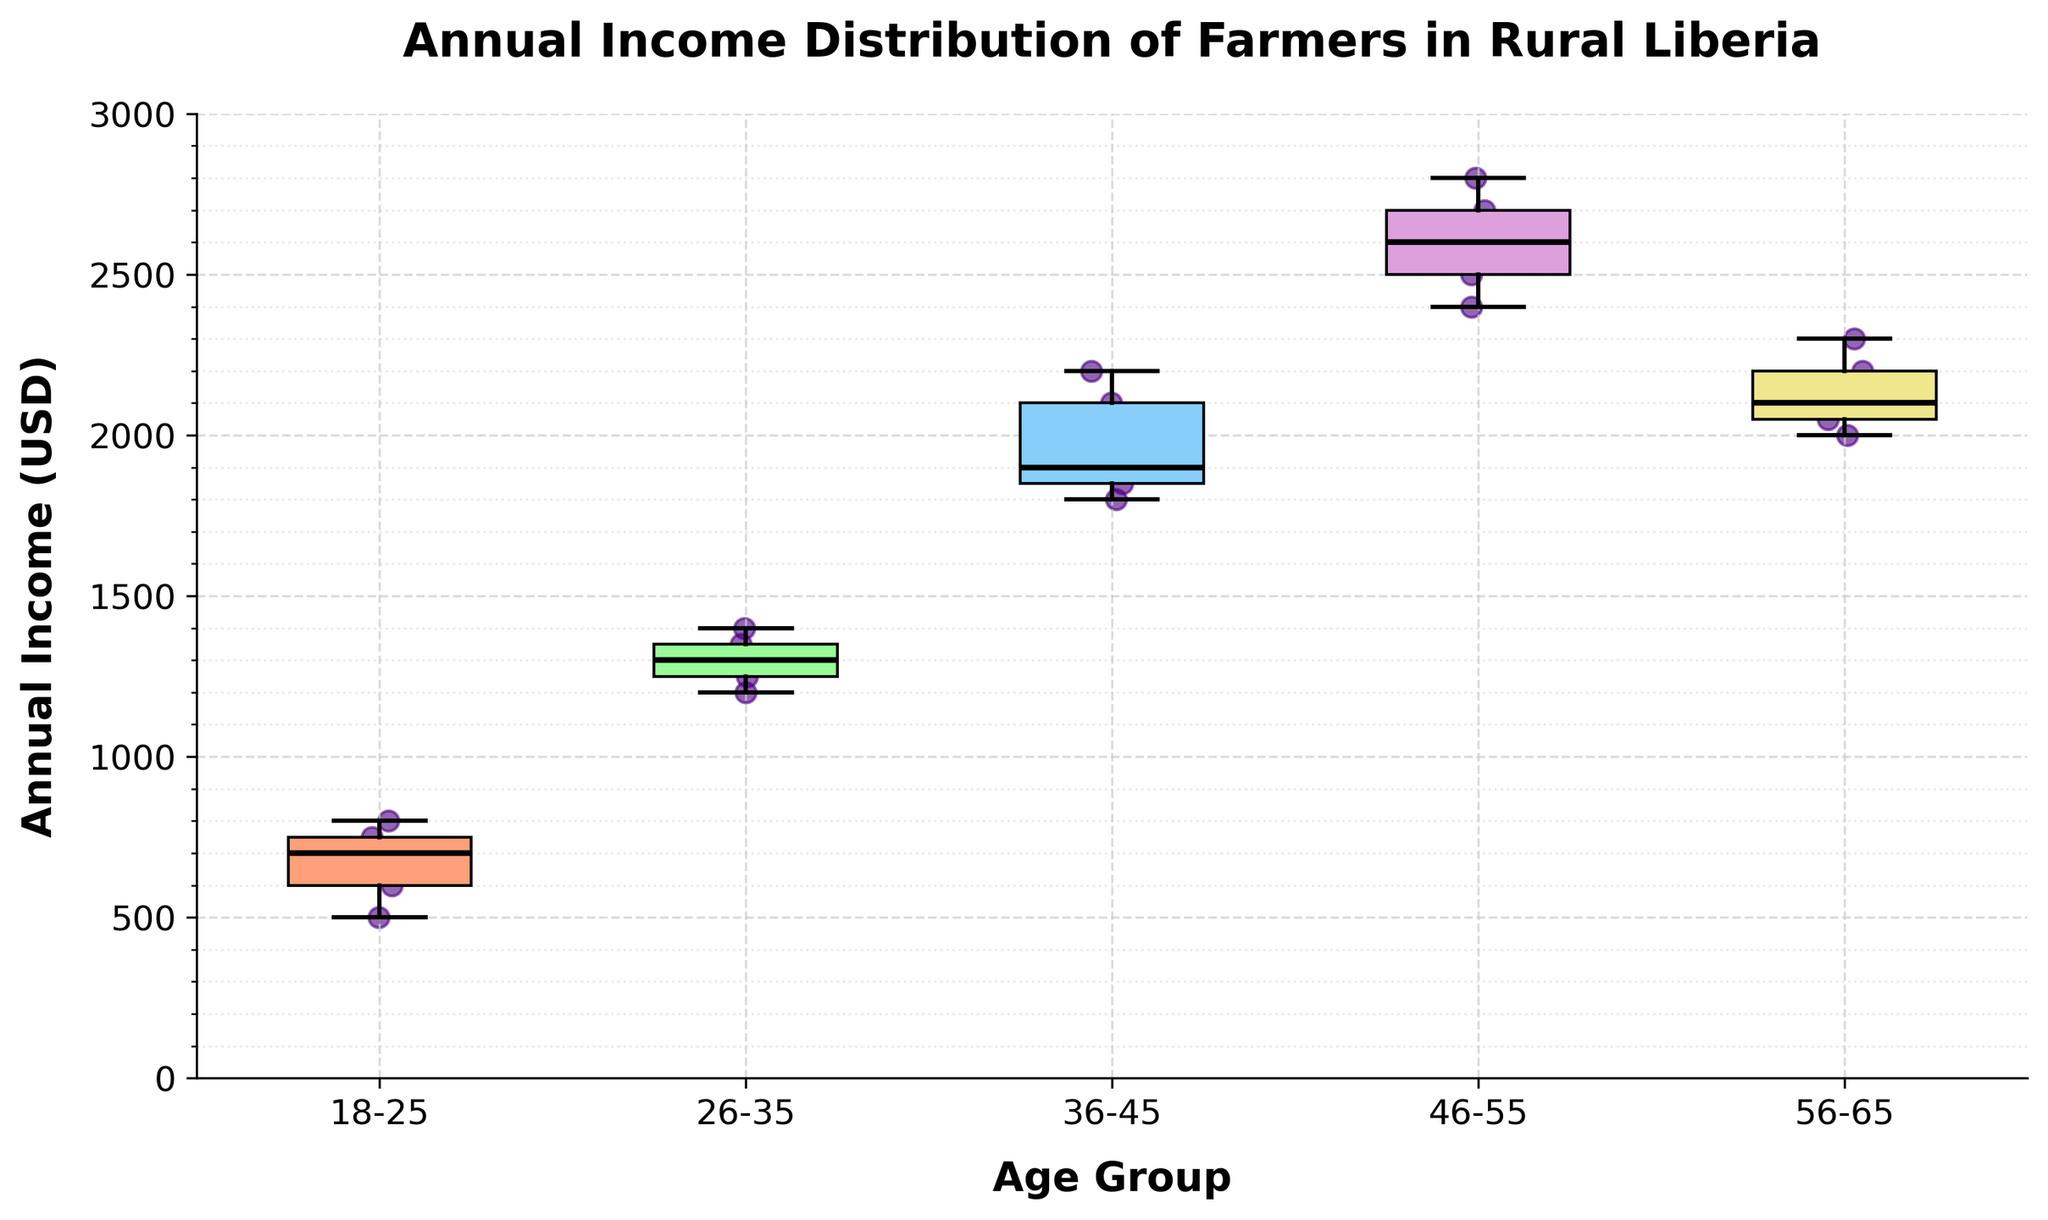What is the title of the box plot? The title of the plot is typically displayed at the top. In this case, it is "Annual Income Distribution of Farmers in Rural Liberia".
Answer: Annual Income Distribution of Farmers in Rural Liberia Which age group has the highest median annual income? The median is marked by a bold black line inside each box. The median for the 46-55 age group appears to be the highest among all groups.
Answer: 46-55 How does the income distribution for the 18-25 age group compare to the 36-45 age group? By looking at the range of incomes represented by each box and whisker plot: the 36-45 group has a higher interquartile range (and overall spread) compared to the 18-25 group. The 36-45 group also has higher median and maximum values.
Answer: 36-45 age group has a higher and wider distribution What is the median annual income for the 36-45 age group? The median is depicted by the central line within the box of the box plot for the 36-45 group. By referencing the plot, the median for this group is around 1900 USD.
Answer: 1900 USD What is the interquartile range (IQR) for the 26-35 age group? IQR is calculated as the difference between the upper quartile (Q3) and lower quartile (Q1). From the box plot, these can be visually estimated. Q3 is approximately 1375 USD and Q1 is around 1250 USD for the 26-35 group. Thus, the IQR is 1375 - 1250 = 125 USD.
Answer: 125 USD Which age group has the widest range of annual income? The range is determined by the span between the lower whisker (minimum value) and the upper whisker (maximum value). The 46-55 age group shows the widest range.
Answer: 46-55 How much higher is the upper whisker (maximum value) for the 56-65 group compared to the 18-25 group? The maximum value for the 56-65 group can be seen at around 2300 USD and for the 18-25 group at 800 USD. The difference is 2300 - 800 = 1500 USD.
Answer: 1500 USD What is the average of the median annual incomes of all age groups? To find the average of the median annual incomes, locate the median of each age group (500, 1300, 1900, 2650, 2100 USD). Sum them up and divide by the number of groups (5). The sum is 500 + 1300 + 1900 + 2650 + 2100 = 8450 USD. The average is 8450/5 = 1690 USD.
Answer: 1690 USD 